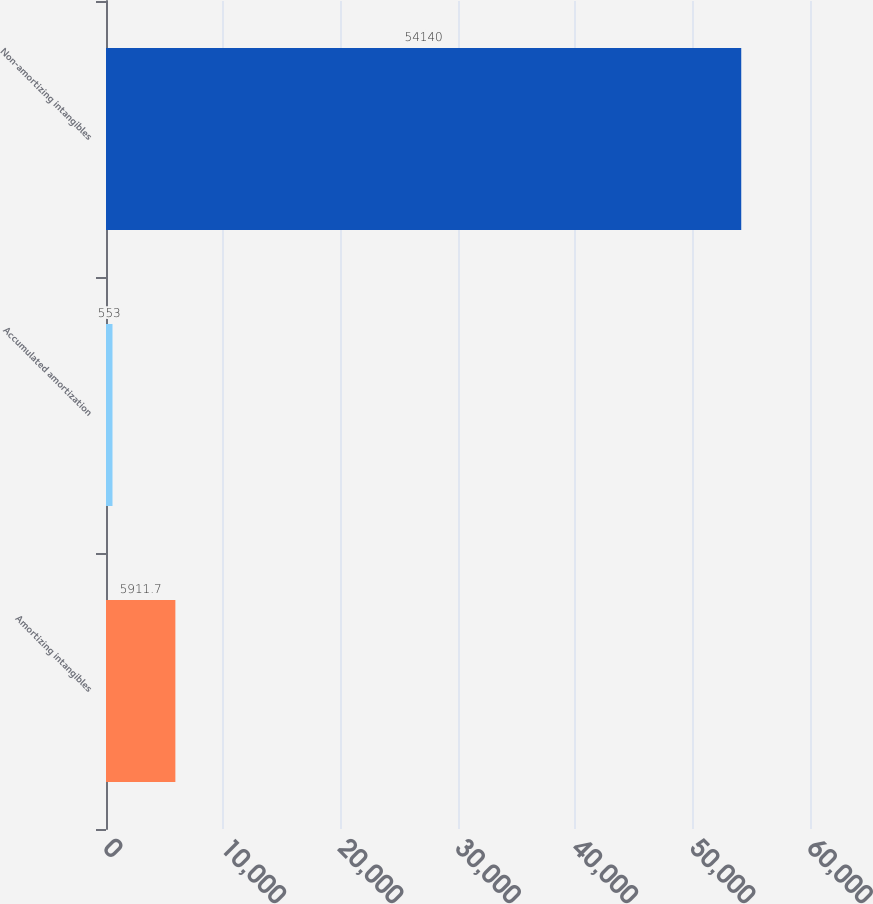Convert chart to OTSL. <chart><loc_0><loc_0><loc_500><loc_500><bar_chart><fcel>Amortizing intangibles<fcel>Accumulated amortization<fcel>Non-amortizing intangibles<nl><fcel>5911.7<fcel>553<fcel>54140<nl></chart> 